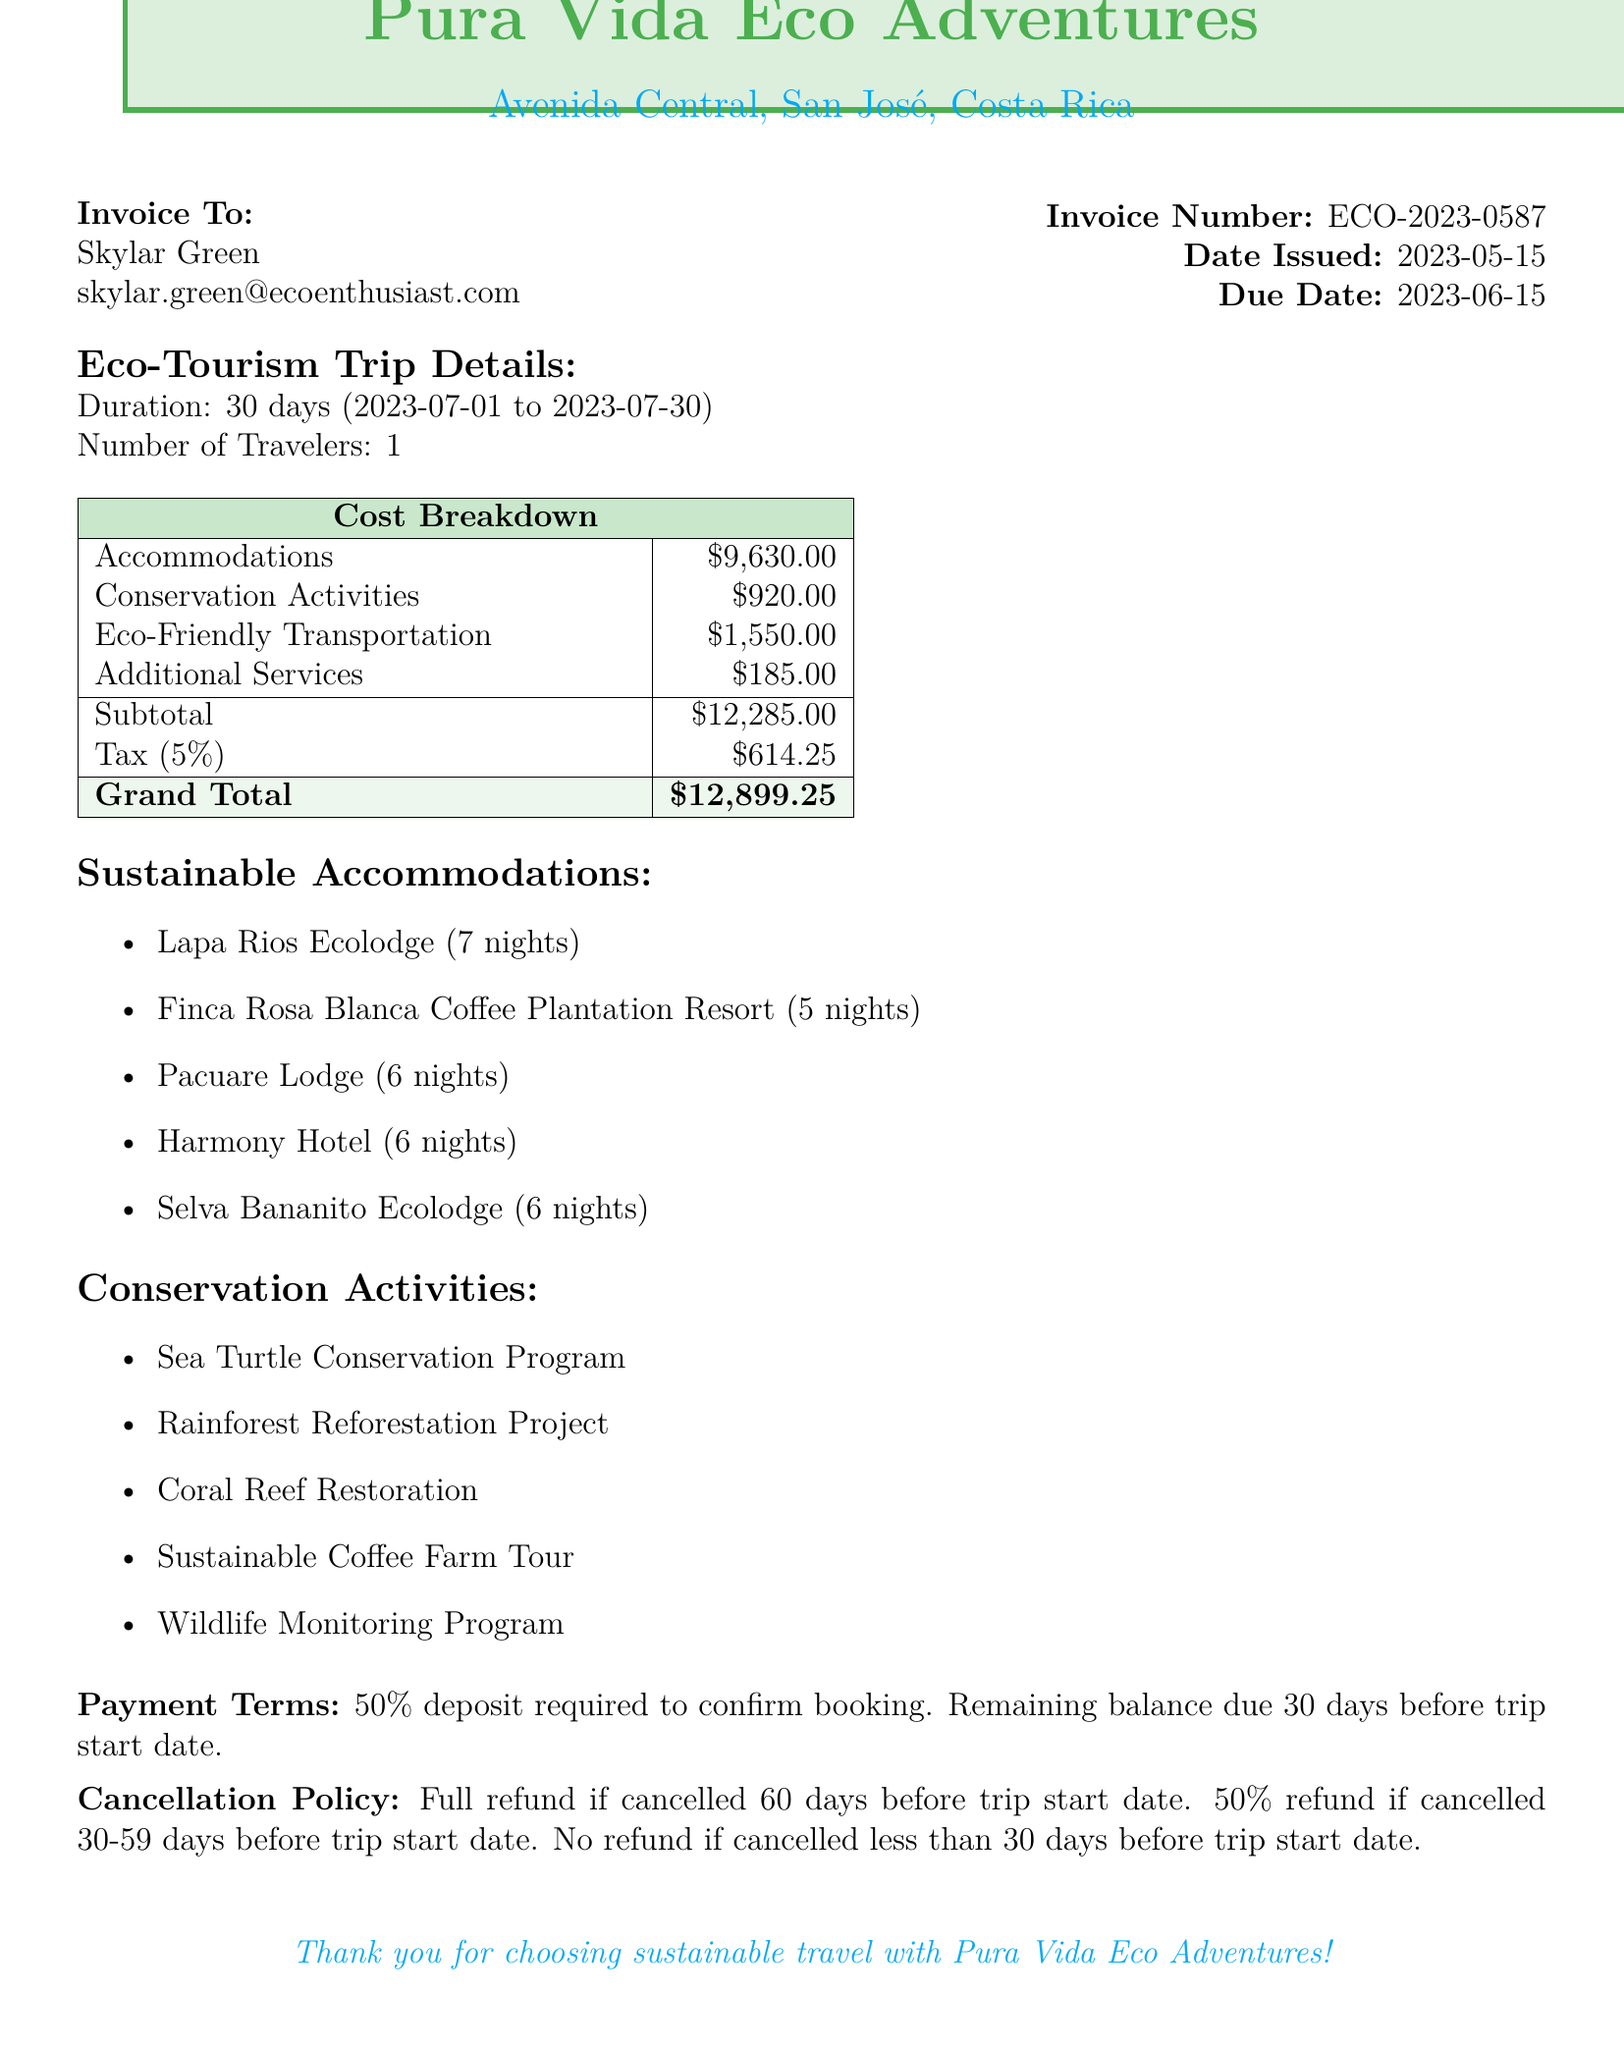What is the invoice number? The invoice number is a unique identifier for the transaction document.
Answer: ECO-2023-0587 What is the total cost of the trip? The total cost reflects the sum of accommodations, conservation activities, transportation, additional services, along with tax.
Answer: 12899.25 How many nights will the traveler stay at Lapa Rios Ecolodge? The number of nights indicates the duration of stay at that specific accommodation.
Answer: 7 What type of transportation is provided? This specifies the mode of transportation arranged for the trip.
Answer: Electric Vehicle Rental What is the duration of the Sea Turtle Conservation Program? This indicates how long the conservation activity will take place.
Answer: 2 days What is the price for the Sustainable Travel Kit? This shows the cost of an additional service included in the trip details.
Answer: 85 What is the cancellation policy for the trip? The cancellation policy outlines the terms under which the traveler can cancel the trip and the corresponding refunds.
Answer: Full refund if cancelled 60 days before trip start date What is the number of travelers for this trip? This is a direct inquiry regarding how many people are participating in the planned trip.
Answer: 1 Where is the Pacuare Lodge located? This asks for the geographical location of one of the accommodations listed in the document.
Answer: Turrialba 